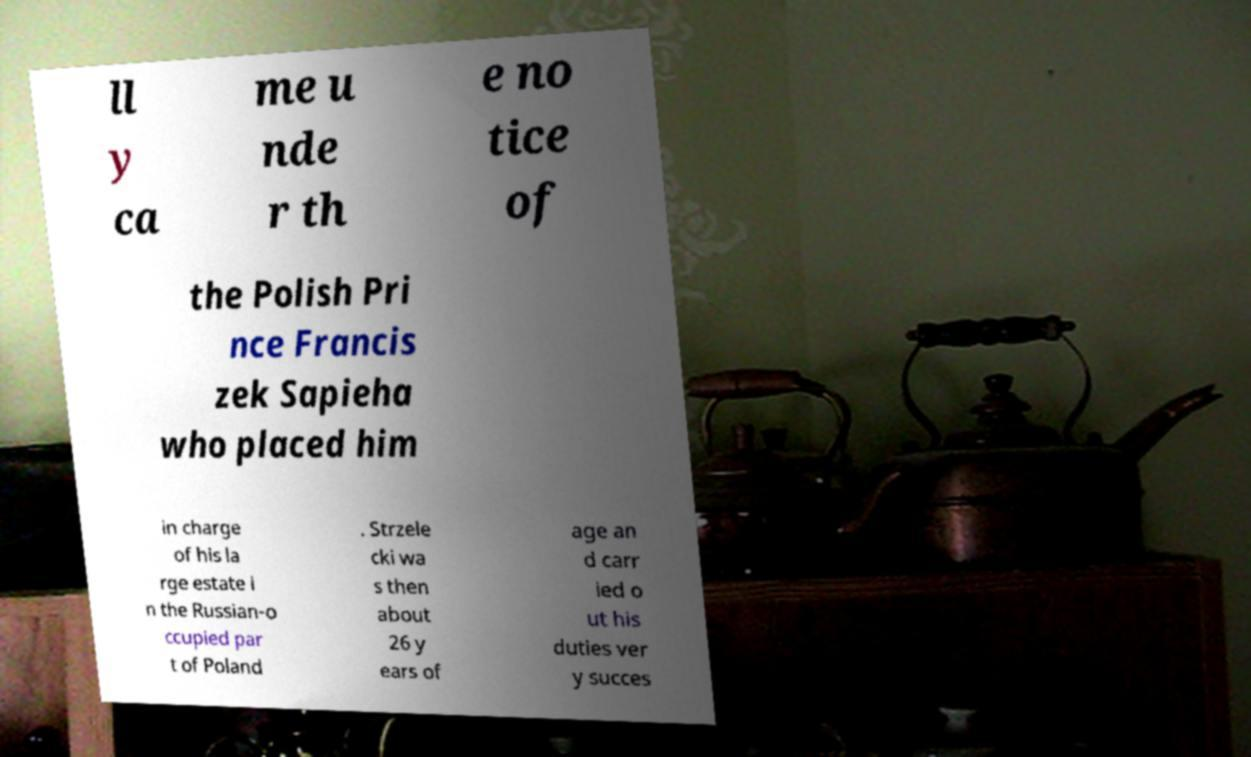Can you accurately transcribe the text from the provided image for me? ll y ca me u nde r th e no tice of the Polish Pri nce Francis zek Sapieha who placed him in charge of his la rge estate i n the Russian-o ccupied par t of Poland . Strzele cki wa s then about 26 y ears of age an d carr ied o ut his duties ver y succes 